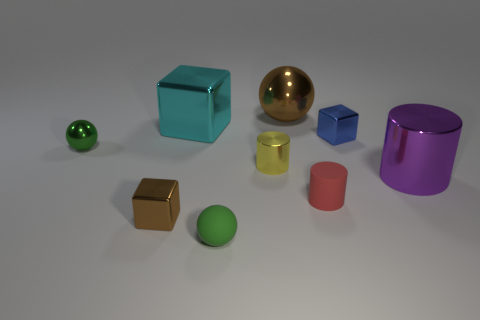There is a green thing that is on the right side of the ball on the left side of the large cyan cube; what number of green metallic balls are behind it?
Keep it short and to the point. 1. Are there any cyan metal things that have the same size as the purple thing?
Provide a succinct answer. Yes. Is the number of blue metallic objects in front of the red cylinder less than the number of metal spheres?
Give a very brief answer. Yes. There is a ball that is behind the small sphere that is left of the brown thing that is in front of the green metallic object; what is its material?
Make the answer very short. Metal. Is the number of things that are on the right side of the big purple object greater than the number of tiny red cylinders right of the small blue metal object?
Keep it short and to the point. No. How many metal things are small brown objects or small brown spheres?
Provide a short and direct response. 1. The tiny thing that is the same color as the matte ball is what shape?
Offer a very short reply. Sphere. There is a small cylinder on the right side of the large brown metal ball; what material is it?
Offer a terse response. Rubber. What number of things are cyan matte spheres or objects that are behind the green matte thing?
Provide a succinct answer. 8. The cyan thing that is the same size as the purple cylinder is what shape?
Offer a very short reply. Cube. 